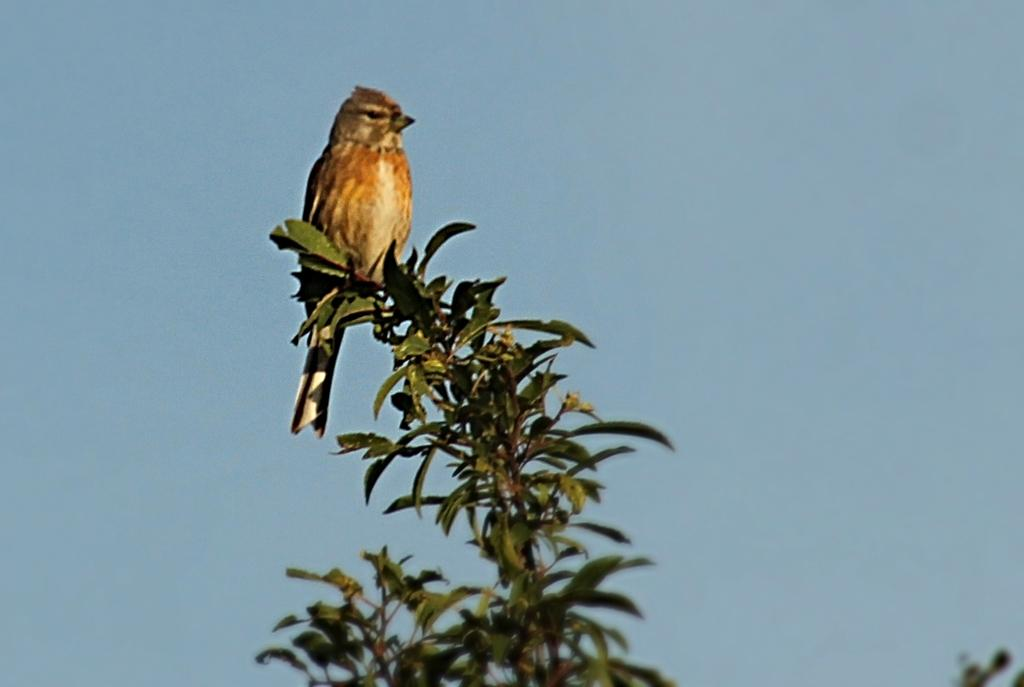What type of animal can be seen in the image? There is a bird in the image. What is the bird perched on in the image? There is a tree in the image. What can be seen in the background of the image? The sky is visible in the background of the image. What type of yak can be seen grazing near the tree in the image? There is no yak present in the image; it features a bird perched on a tree. Can you recite the verse that is written on the tree in the image? There is no verse written on the tree in the image; it is a natural tree with no text or markings. 